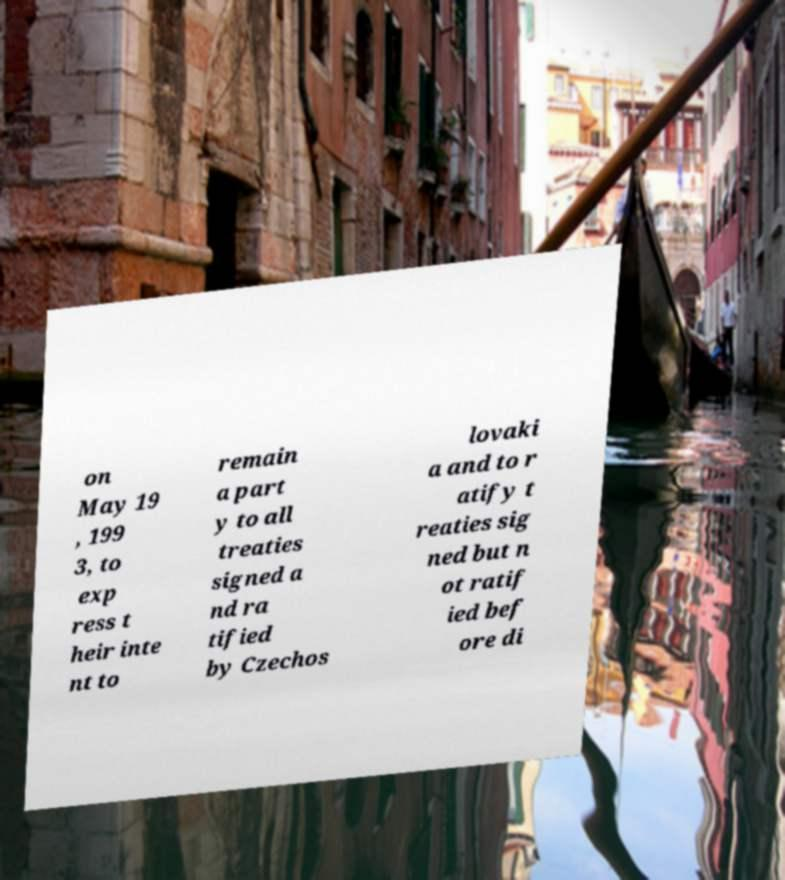I need the written content from this picture converted into text. Can you do that? on May 19 , 199 3, to exp ress t heir inte nt to remain a part y to all treaties signed a nd ra tified by Czechos lovaki a and to r atify t reaties sig ned but n ot ratif ied bef ore di 